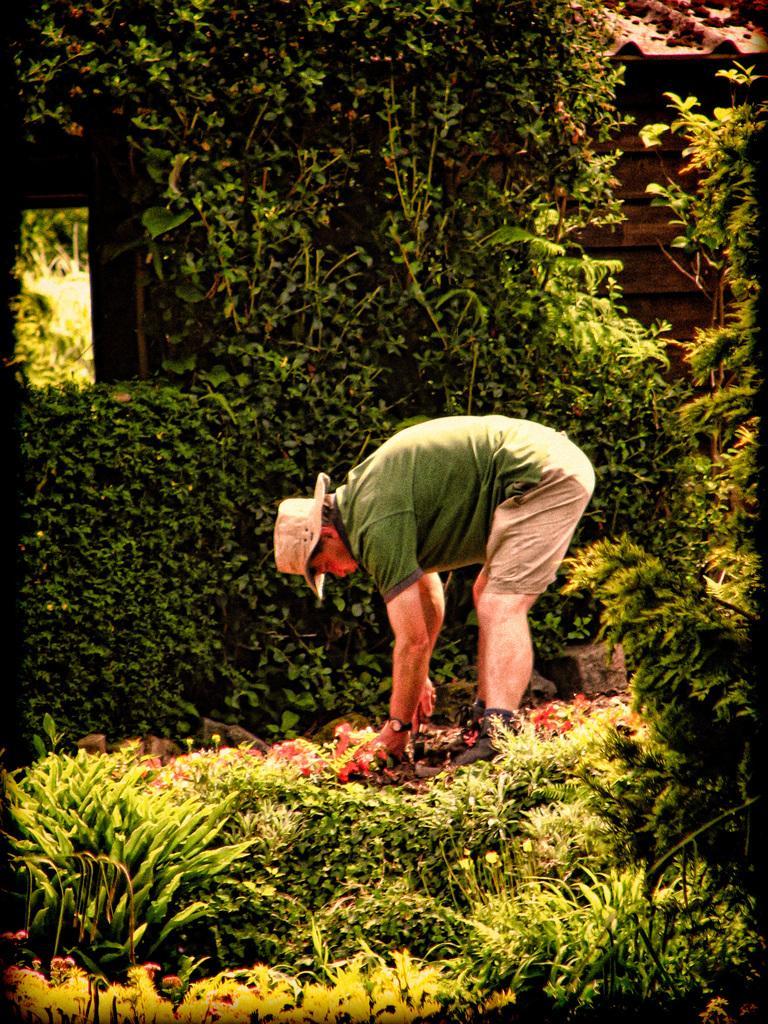How would you summarize this image in a sentence or two? In this image we can see a person wearing a cap and holding an object and we can also see some plants. 